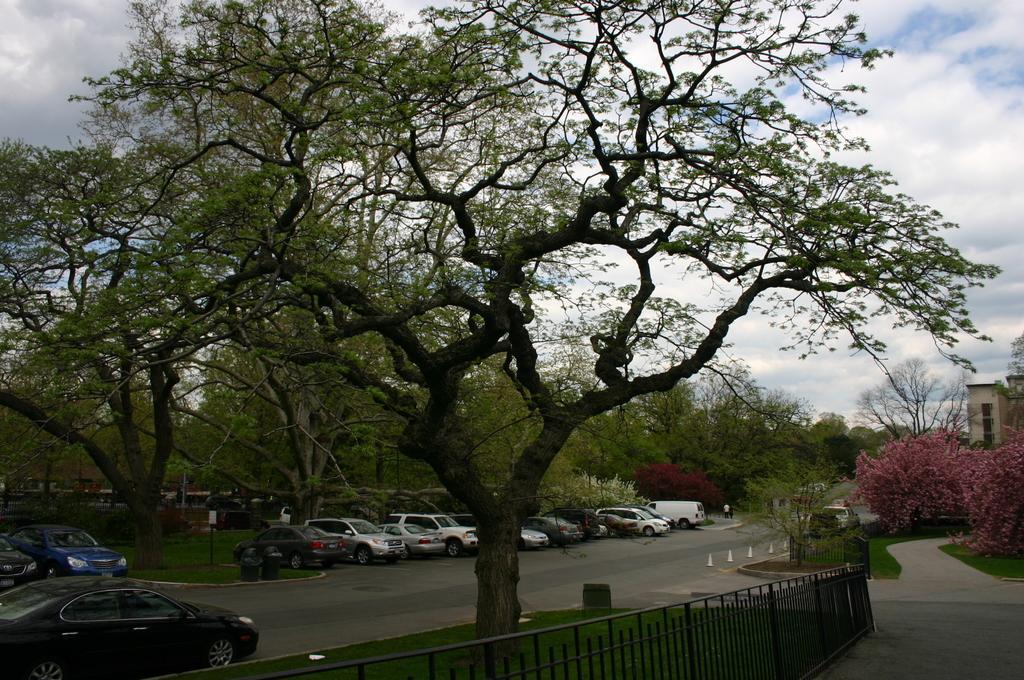Describe this image in one or two sentences. In this picture we can see few vehicles, trees, sign boards and group of people, at the bottom of the image we can find fence, in the background we can see flowers and a building. 